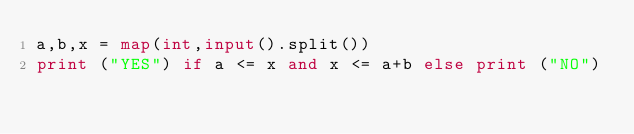<code> <loc_0><loc_0><loc_500><loc_500><_Python_>a,b,x = map(int,input().split())
print ("YES") if a <= x and x <= a+b else print ("NO")
</code> 